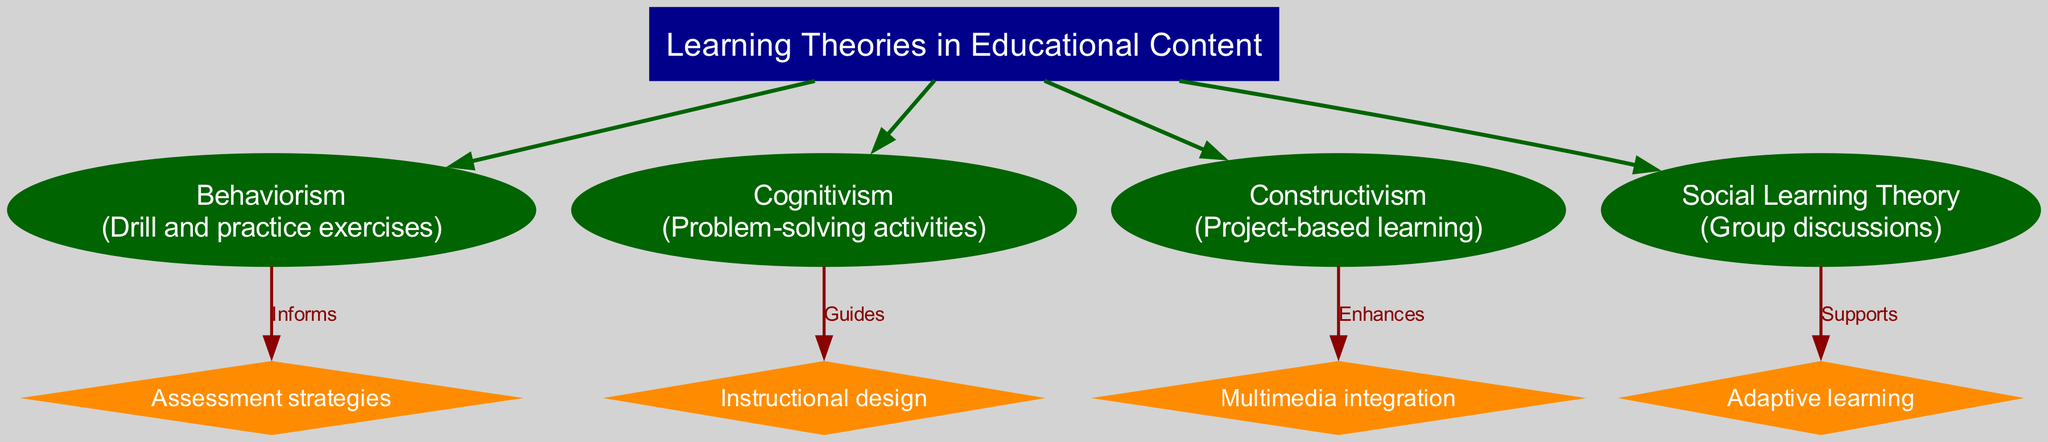What is the central concept of the diagram? The diagram clearly labels the central concept as "Learning Theories in Educational Content". This can be found at the top of the diagram, set within a distinct box.
Answer: Learning Theories in Educational Content How many main theories are represented in the diagram? The diagram includes four main theories: Behaviorism, Cognitivism, Constructivism, and Social Learning Theory. Each is connected to the central concept, making it straightforward to count them directly.
Answer: 4 What application is associated with Cognitivism? Under the main theories section, Cognitivism is associated with "Problem-solving activities" as indicated in the diagram next to the name of this theory. This direct relationship can be easily identified.
Answer: Problem-solving activities Which theory enhances multimedia integration? The diagram specifies that Constructivism enhances multimedia integration. This can be deduced by looking at the label next to the connection from Constructivism to multimedia integration in the diagram.
Answer: Constructivism What does Social Learning Theory support? The diagram indicates that Social Learning Theory supports adaptive learning. This relationship is stated in the connection label between the two nodes, clearly defining the support role of Social Learning Theory.
Answer: Adaptive learning Which content development aspect does Behaviorism inform? The diagram states that Behaviorism informs assessment strategies. This can be verified by tracing the connection from the Behaviorism node to the assessment strategies node in the diagram.
Answer: Assessment strategies How does Cognitivism guide instructional design? The connection in the diagram shows that Cognitivism guides instructional design. This is evident by following the edge labeled "Guides" from Cognitivism to instructional design, illustrating the relationship clearly.
Answer: Guides What type of learning does Constructivism apply? The diagram shows that Constructivism applies to project-based learning. This application is noted in the description next to Constructivism, making it easy to identify the type of learning involved.
Answer: Project-based learning What are the roles of the four main theories in content development? By analyzing the connections in the diagram, Behaviorism informs assessment strategies, Cognitivism guides instructional design, Constructivism enhances multimedia integration, and Social Learning Theory supports adaptive learning. This comprehensive view can be seen by looking at the edges labeling these relationships.
Answer: Informs, Guides, Enhances, Supports 